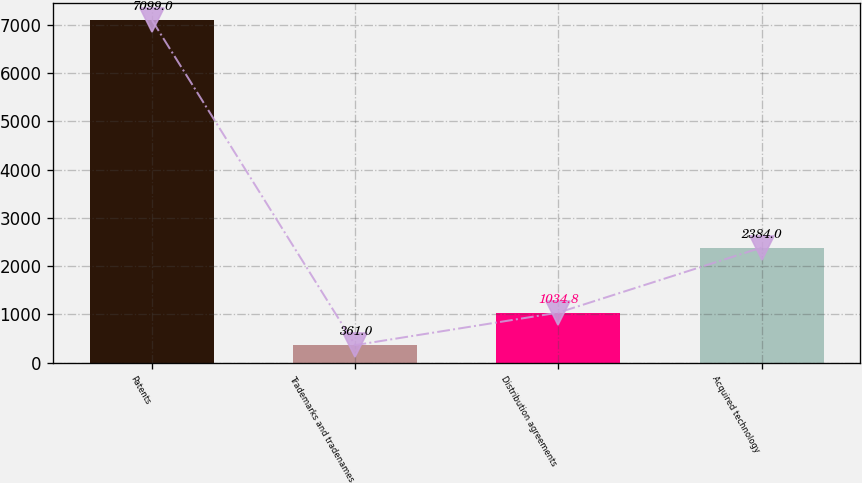Convert chart to OTSL. <chart><loc_0><loc_0><loc_500><loc_500><bar_chart><fcel>Patents<fcel>Trademarks and tradenames<fcel>Distribution agreements<fcel>Acquired technology<nl><fcel>7099<fcel>361<fcel>1034.8<fcel>2384<nl></chart> 